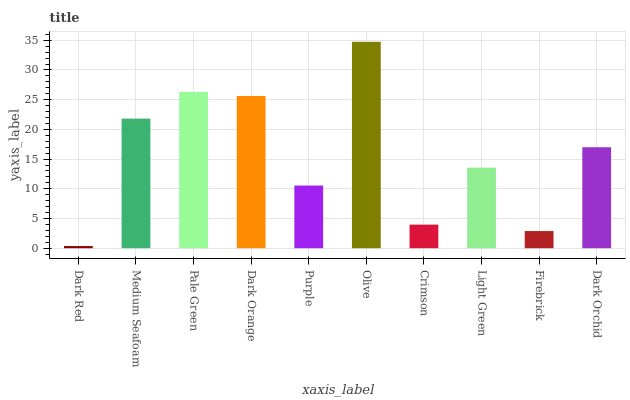Is Medium Seafoam the minimum?
Answer yes or no. No. Is Medium Seafoam the maximum?
Answer yes or no. No. Is Medium Seafoam greater than Dark Red?
Answer yes or no. Yes. Is Dark Red less than Medium Seafoam?
Answer yes or no. Yes. Is Dark Red greater than Medium Seafoam?
Answer yes or no. No. Is Medium Seafoam less than Dark Red?
Answer yes or no. No. Is Dark Orchid the high median?
Answer yes or no. Yes. Is Light Green the low median?
Answer yes or no. Yes. Is Olive the high median?
Answer yes or no. No. Is Dark Red the low median?
Answer yes or no. No. 